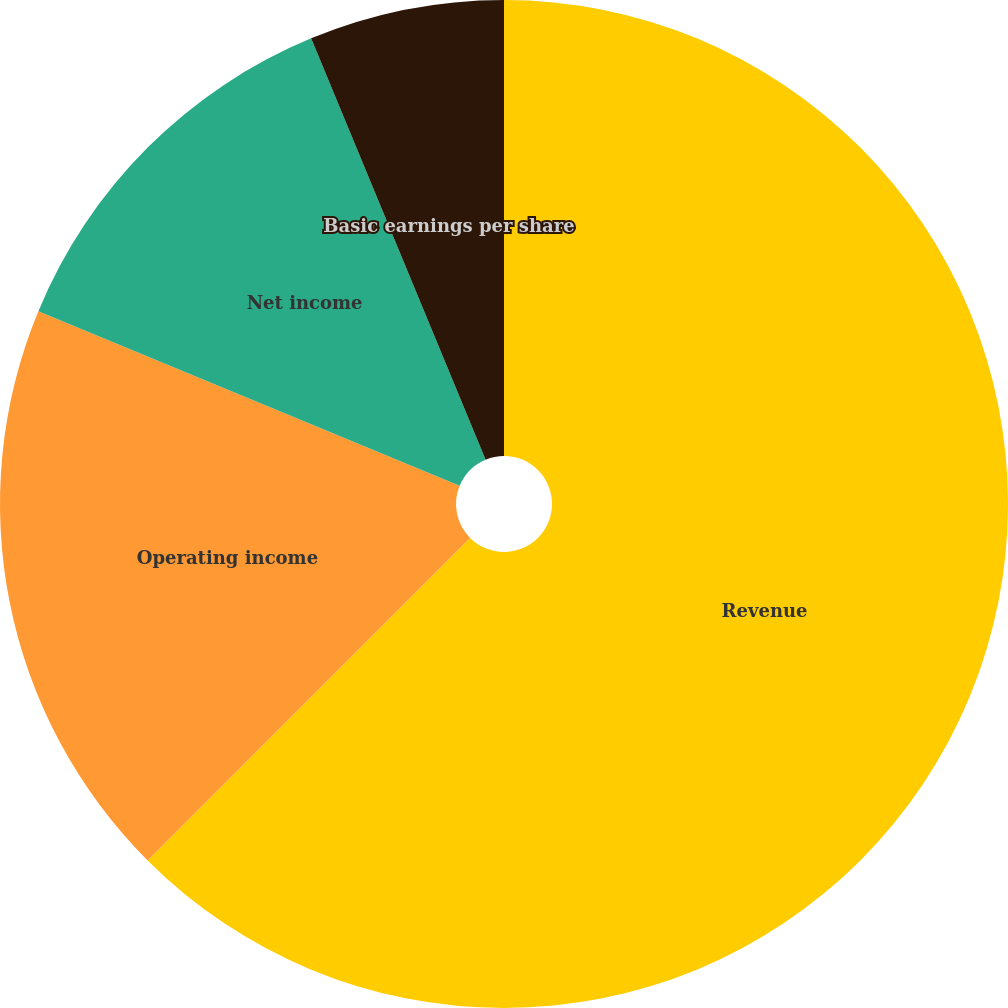<chart> <loc_0><loc_0><loc_500><loc_500><pie_chart><fcel>Revenue<fcel>Operating income<fcel>Net income<fcel>Basic earnings per share<fcel>Diluted earnings per share<nl><fcel>62.5%<fcel>18.75%<fcel>12.5%<fcel>6.25%<fcel>0.0%<nl></chart> 